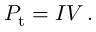<formula> <loc_0><loc_0><loc_500><loc_500>P _ { t } = I V \, .</formula> 